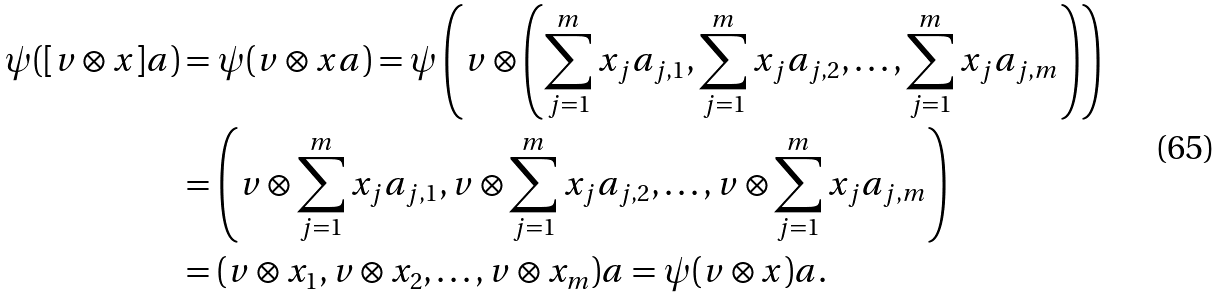Convert formula to latex. <formula><loc_0><loc_0><loc_500><loc_500>\psi ( [ v \otimes x ] a ) & = \psi ( v \otimes x a ) = \psi \left ( v \otimes \left ( \sum _ { j = 1 } ^ { m } x _ { j } a _ { j , 1 } , \sum _ { j = 1 } ^ { m } x _ { j } a _ { j , 2 } , \dots , \sum _ { j = 1 } ^ { m } x _ { j } a _ { j , m } \right ) \right ) \\ & = \left ( v \otimes \sum _ { j = 1 } ^ { m } x _ { j } a _ { j , 1 } , v \otimes \sum _ { j = 1 } ^ { m } x _ { j } a _ { j , 2 } , \dots , v \otimes \sum _ { j = 1 } ^ { m } x _ { j } a _ { j , m } \right ) \\ & = ( v \otimes x _ { 1 } , v \otimes x _ { 2 } , \dots , v \otimes x _ { m } ) a = \psi ( v \otimes x ) a .</formula> 